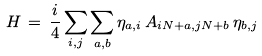<formula> <loc_0><loc_0><loc_500><loc_500>H \, = \, \frac { i } { 4 } \sum _ { i , j } \sum _ { a , b } \eta _ { a , i } \, A _ { i N + a , j N + b } \, \eta _ { b , j }</formula> 